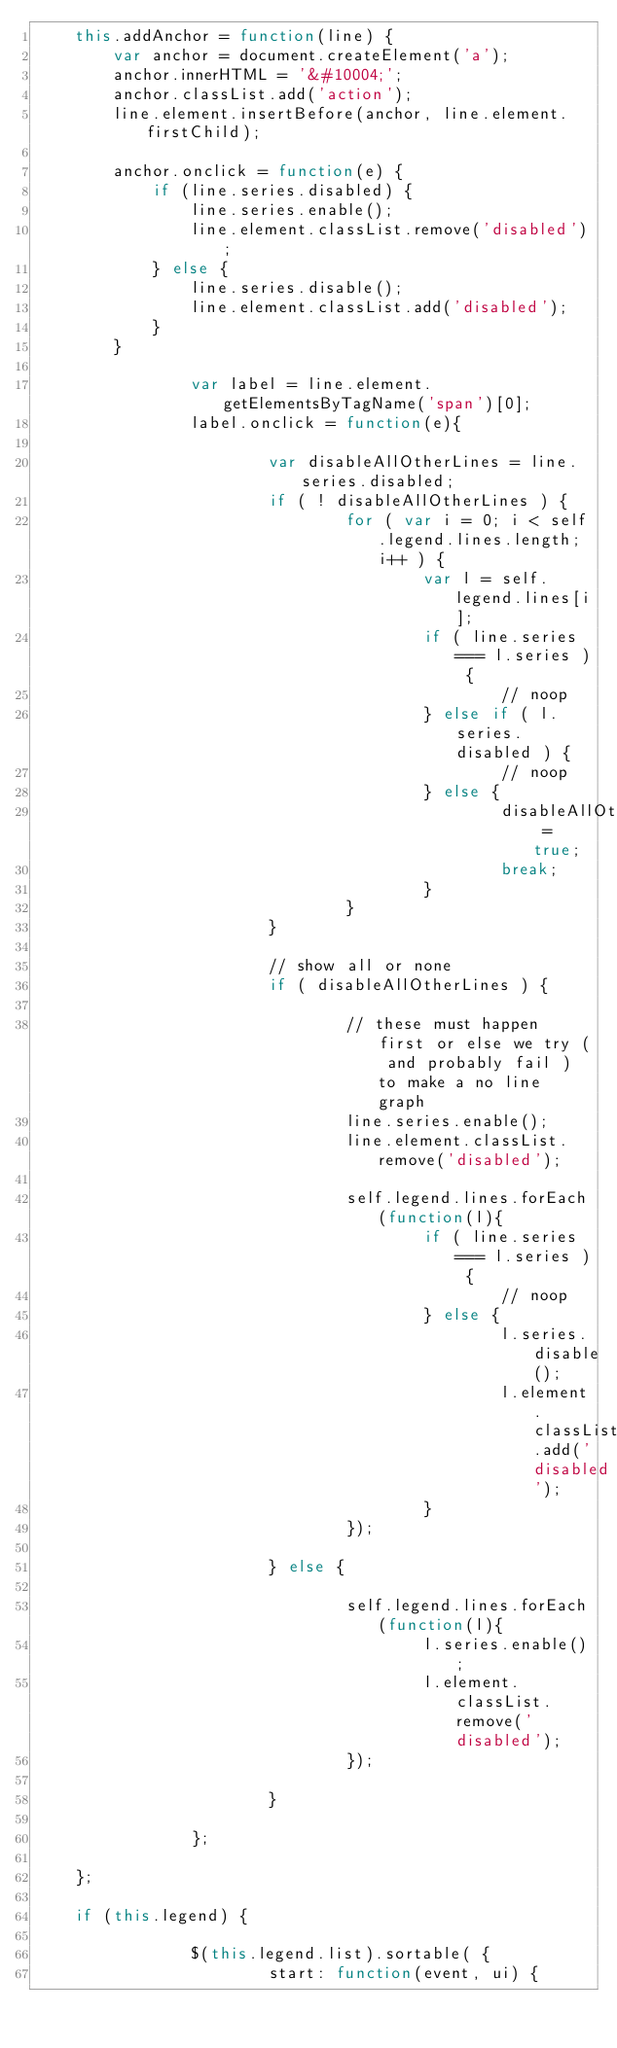<code> <loc_0><loc_0><loc_500><loc_500><_JavaScript_>	this.addAnchor = function(line) {
		var anchor = document.createElement('a');
		anchor.innerHTML = '&#10004;';
		anchor.classList.add('action');
		line.element.insertBefore(anchor, line.element.firstChild);

		anchor.onclick = function(e) {
			if (line.series.disabled) {
				line.series.enable();
				line.element.classList.remove('disabled');
			} else { 
				line.series.disable();
				line.element.classList.add('disabled');
			}
		}
		
                var label = line.element.getElementsByTagName('span')[0];
                label.onclick = function(e){

                        var disableAllOtherLines = line.series.disabled;
                        if ( ! disableAllOtherLines ) {
                                for ( var i = 0; i < self.legend.lines.length; i++ ) {
                                        var l = self.legend.lines[i];
                                        if ( line.series === l.series ) {
                                                // noop
                                        } else if ( l.series.disabled ) {
                                                // noop
                                        } else {
                                                disableAllOtherLines = true;
                                                break;
                                        }
                                }
                        }

                        // show all or none
                        if ( disableAllOtherLines ) {

                                // these must happen first or else we try ( and probably fail ) to make a no line graph
                                line.series.enable();
                                line.element.classList.remove('disabled');

                                self.legend.lines.forEach(function(l){
                                        if ( line.series === l.series ) {
                                                // noop
                                        } else {
                                                l.series.disable();
                                                l.element.classList.add('disabled');
                                        }
                                });

                        } else {

                                self.legend.lines.forEach(function(l){
                                        l.series.enable();
                                        l.element.classList.remove('disabled');
                                });

                        }

                };

	};

	if (this.legend) {

                $(this.legend.list).sortable( {
                        start: function(event, ui) {</code> 